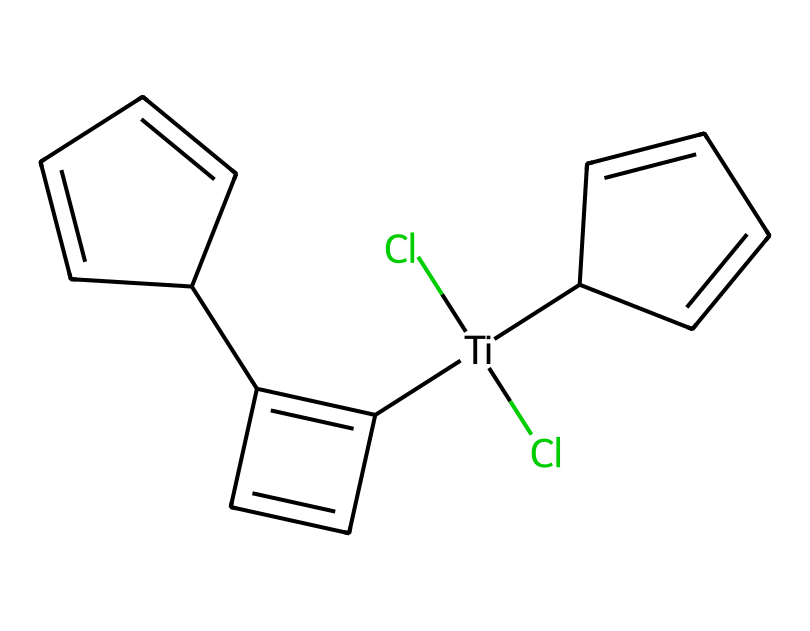What is the central metal atom in titanocene dichloride? The chemical structure contains titanium, which is indicated by the atomic symbol "Ti" in the SMILES representation.
Answer: titanium How many chlorine atoms are present in the compound? The SMILES representation shows "Cl" twice next to the titanium atom, indicating there are two chlorine atoms.
Answer: two What type of bonding is primarily present between titanium and the chlorine atoms? The bonds represented between "Ti" and "Cl" are coordination bonds, typical in organometallic complexes involving transition metals and halides.
Answer: coordination bonds What is the overall geometry of the titanocene dichloride complex? The arrangement suggests an octahedral geometry due to the presence of a central titanium atom surrounded by two chlorides and two cyclopentadienyl ligands, characteristic of metallocenes.
Answer: octahedral Which part of titanocene dichloride contributes to its potential biological activity? The cyclopentadienyl ligands, which can influence the interaction with biological molecules and may play a role in its anticancer properties.
Answer: cyclopentadienyl ligands What is the total number of carbon atoms in the structure? By analyzing the structure, there are ten carbon atoms from two cyclopentadienyl rings (5 each) connected to the titanium center.
Answer: ten 